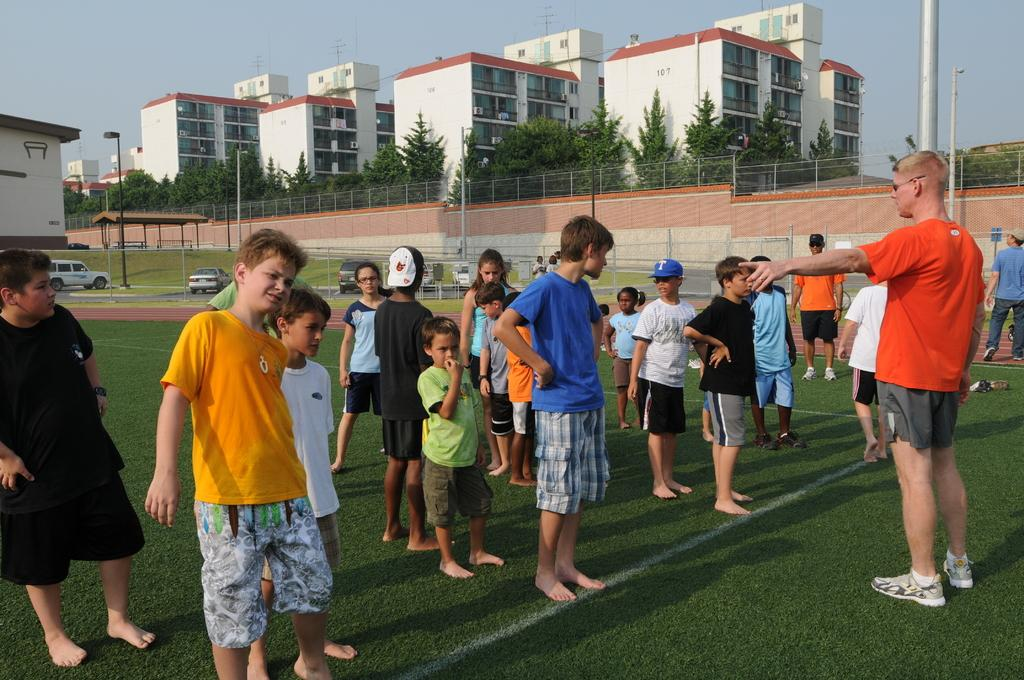What type of vegetation covers the land in the image? The land is covered with grass. Can you describe the people in the image? There are people in the image, but their specific actions or appearances are not mentioned in the facts. What can be seen in the distance in the image? In the background, there are buildings, light poles, trees, vehicles, and a fence. How many elements can be identified in the background? There are five elements present in the background: buildings, light poles, trees, vehicles, and a fence. What type of beam is being used to push the vehicles in the image? There is no beam or pushing of vehicles present in the image. What type of bomb can be seen in the image? There is no bomb present in the image. 